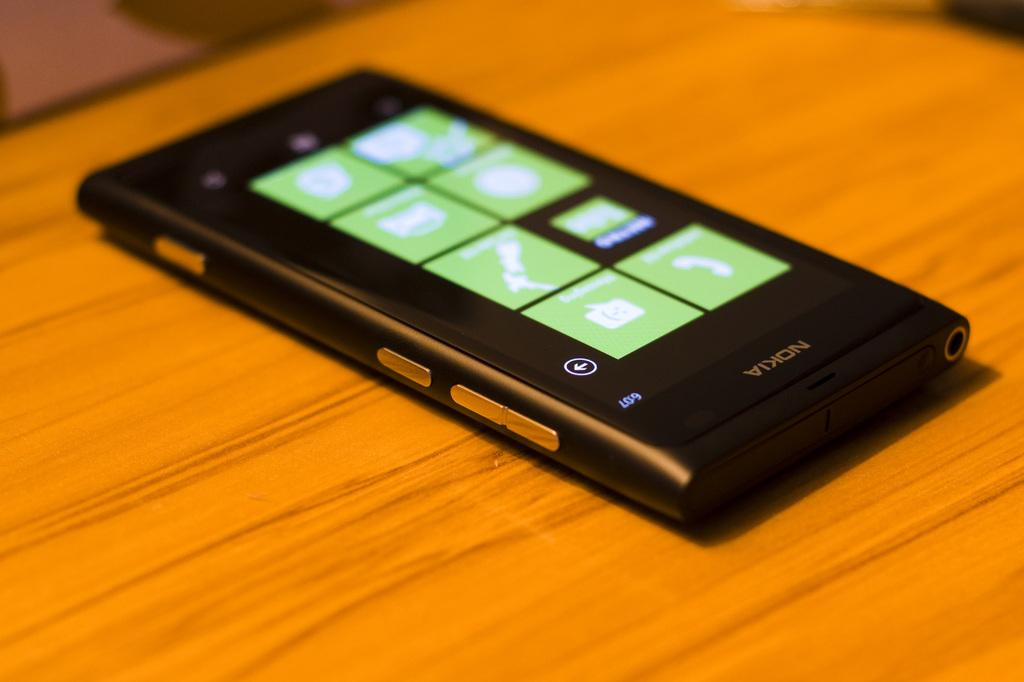<image>
Write a terse but informative summary of the picture. A black Nokia smart phone on a wooden table. 